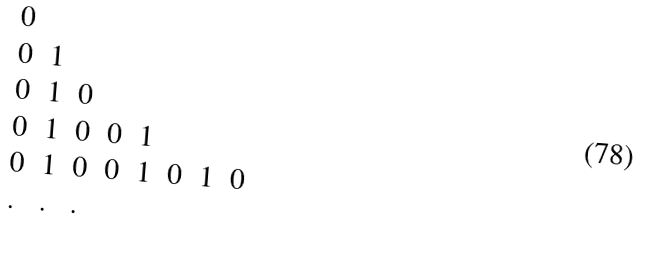<formula> <loc_0><loc_0><loc_500><loc_500>\begin{array} { l l l l l l l l } 0 & & & & & & & \\ 0 & 1 & & & & & & \\ 0 & 1 & 0 & & & & & \\ 0 & 1 & 0 & 0 & 1 & & & \\ 0 & 1 & 0 & 0 & 1 & 0 & 1 & 0 \\ . & . & . & & & & & \\ \end{array}</formula> 